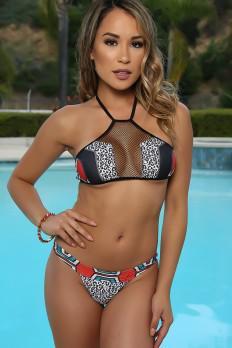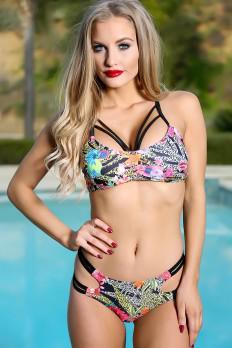The first image is the image on the left, the second image is the image on the right. For the images shown, is this caption "The swimsuit in the image on the left has a floral print." true? Answer yes or no. No. 